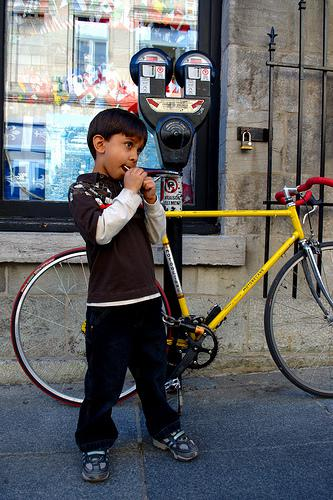Question: where is the kid standing in relation to the bike?
Choices:
A. Behind the bike.
B. In front of the bike.
C. To the left of the bike.
D. Right of the bike.
Answer with the letter. Answer: B Question: what does the kid have in his mouth?
Choices:
A. Ice Cream.
B. Chocolate bar.
C. Pizza.
D. Candy.
Answer with the letter. Answer: D Question: how is the door behind him locked?
Choices:
A. With a switch.
B. With a rope.
C. With a combination.
D. With a lock.
Answer with the letter. Answer: D Question: what is the bike parked by?
Choices:
A. Parking meter.
B. Food truck.
C. Fire hydrant.
D. Bike shop.
Answer with the letter. Answer: A Question: what is the kid standing on?
Choices:
A. The steps.
B. The curb.
C. The lawn.
D. The sidewalk.
Answer with the letter. Answer: D 